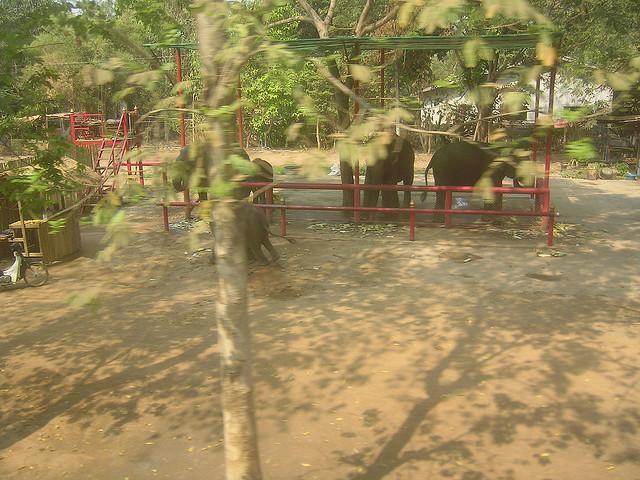How many elephants are there?
Give a very brief answer. 2. 